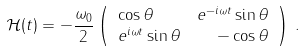Convert formula to latex. <formula><loc_0><loc_0><loc_500><loc_500>\mathcal { H } ( t ) & = - \frac { \omega _ { 0 } } { 2 } \left ( \begin{array} { l r } \cos \theta & e ^ { - i \omega t } \sin \theta \\ e ^ { i \omega t } \sin \theta & - \cos \theta \end{array} \right ) \, .</formula> 